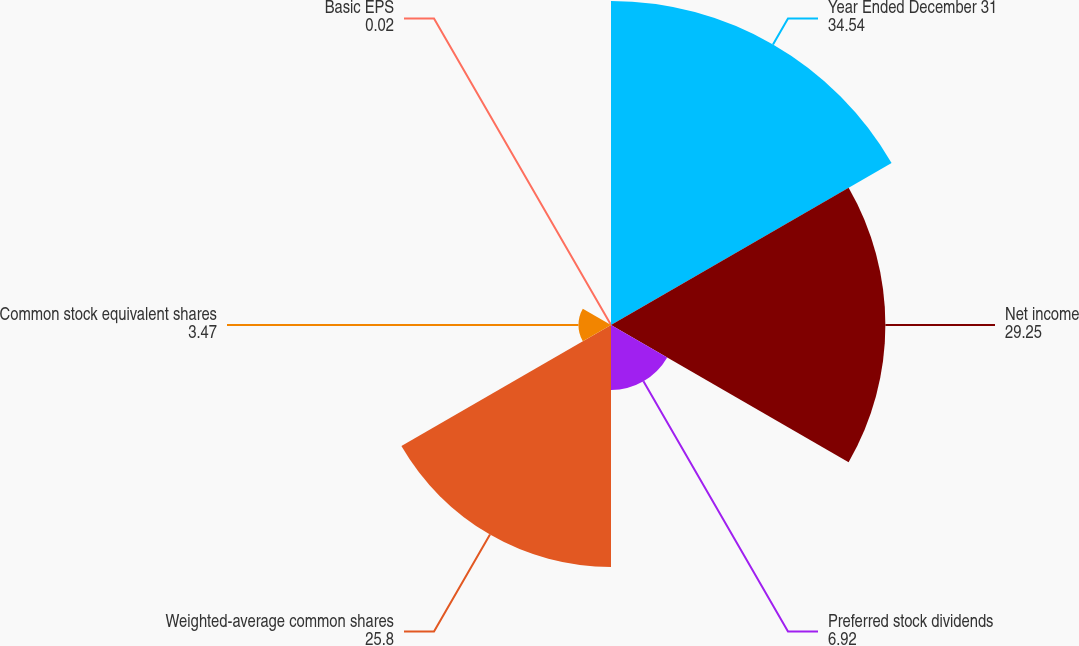Convert chart. <chart><loc_0><loc_0><loc_500><loc_500><pie_chart><fcel>Year Ended December 31<fcel>Net income<fcel>Preferred stock dividends<fcel>Weighted-average common shares<fcel>Common stock equivalent shares<fcel>Basic EPS<nl><fcel>34.54%<fcel>29.25%<fcel>6.92%<fcel>25.8%<fcel>3.47%<fcel>0.02%<nl></chart> 